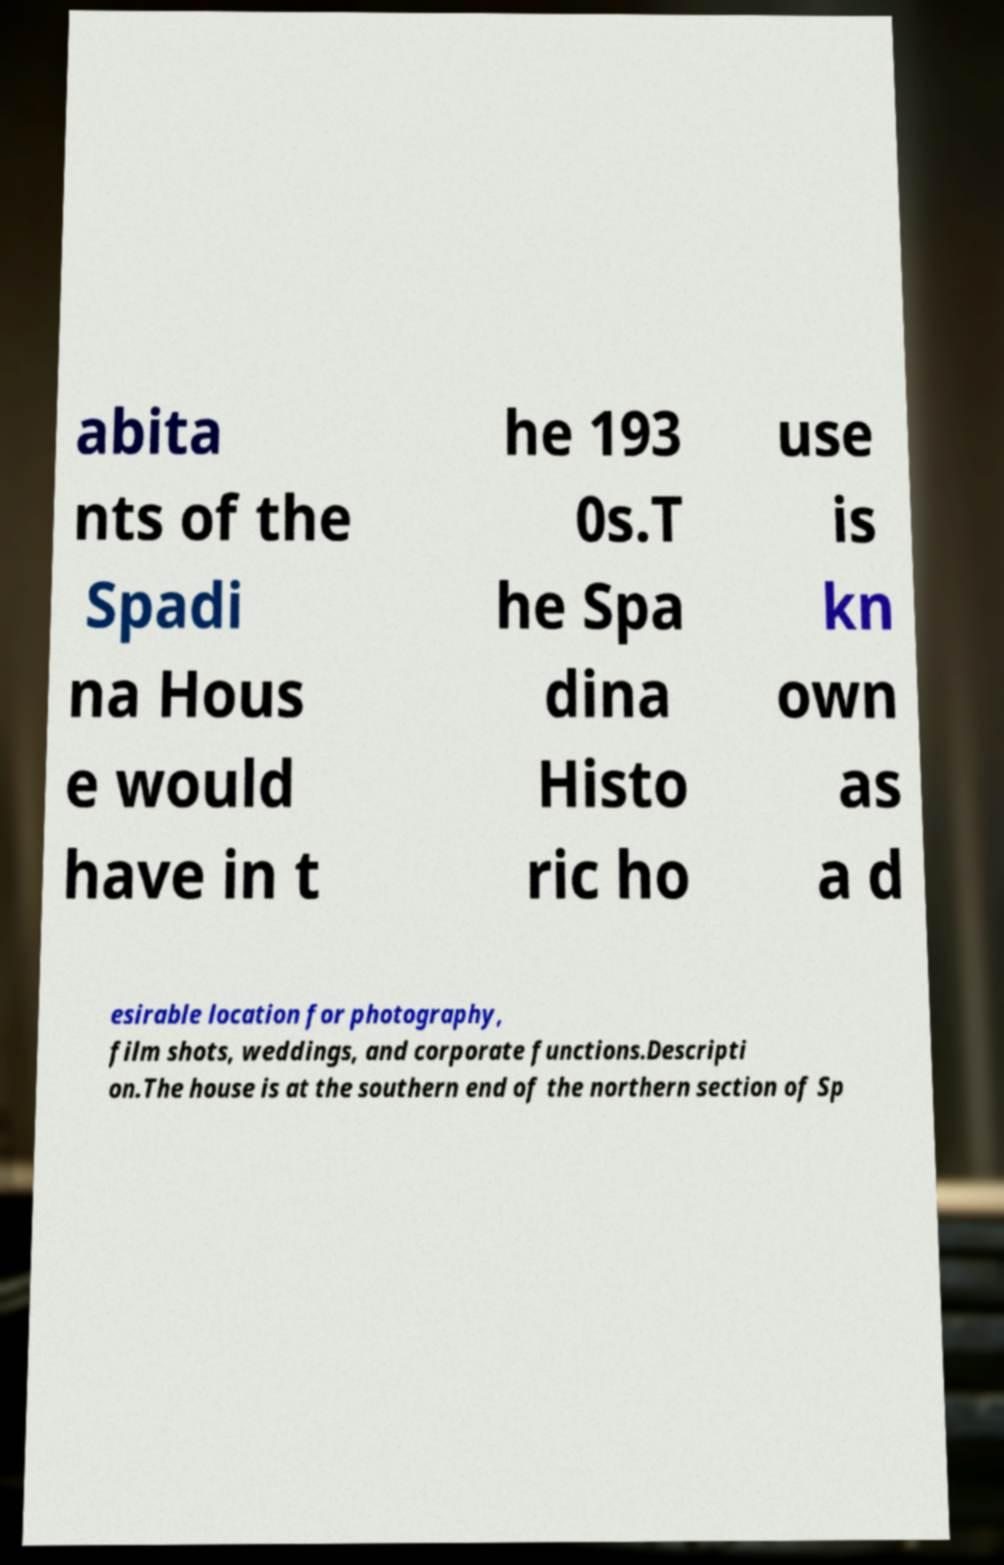Could you extract and type out the text from this image? abita nts of the Spadi na Hous e would have in t he 193 0s.T he Spa dina Histo ric ho use is kn own as a d esirable location for photography, film shots, weddings, and corporate functions.Descripti on.The house is at the southern end of the northern section of Sp 